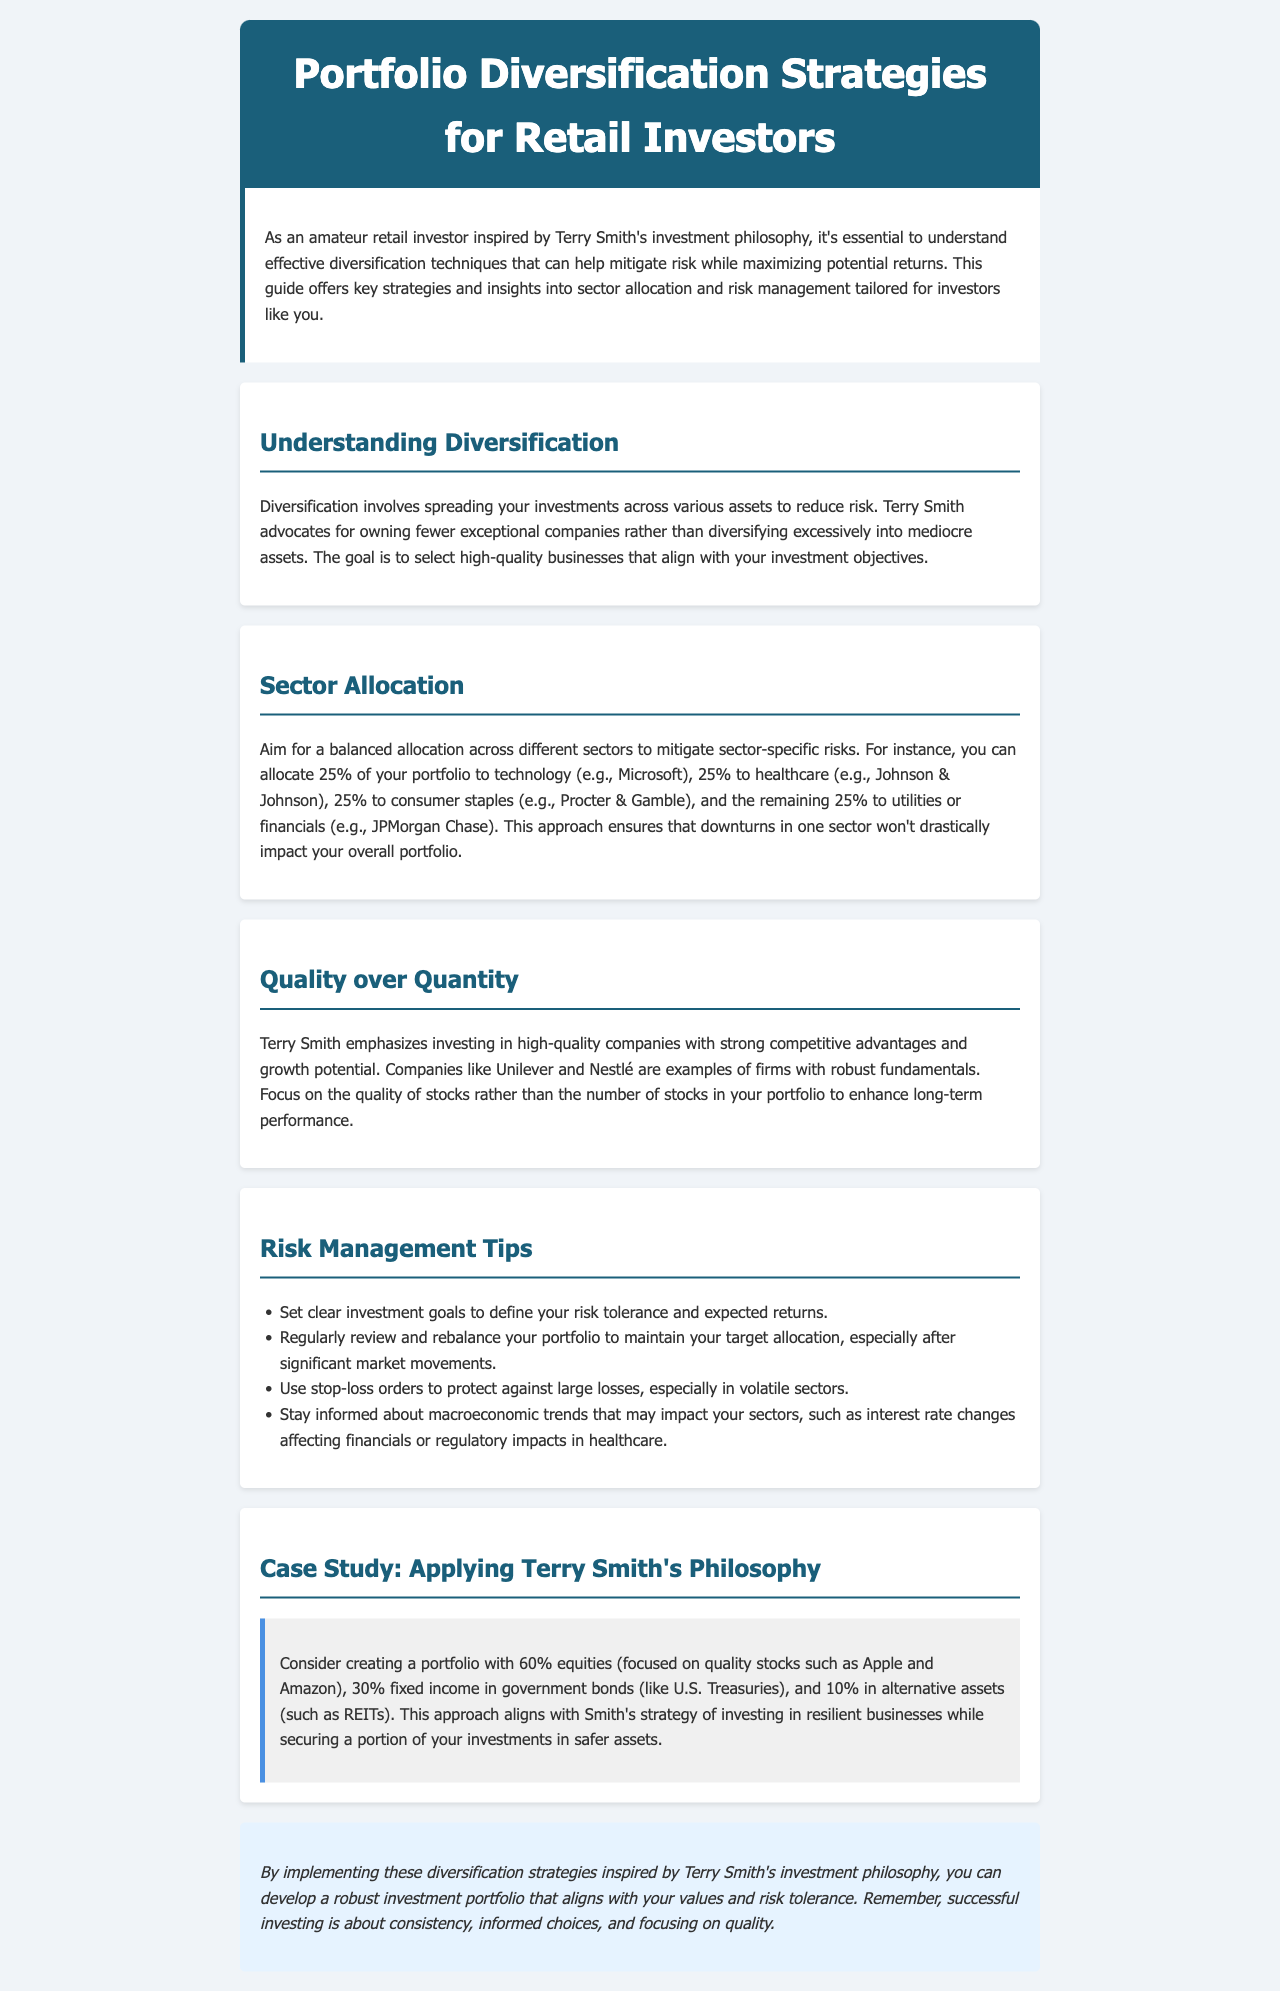What is the title of the document? The title of the document is presented in the header section of the newsletter.
Answer: Portfolio Diversification Strategies for Retail Investors What is Terry Smith's investment philosophy emphasized in the newsletter? The newsletter highlights Terry Smith's focus on investing in high-quality companies rather than diversifying excessively into mediocre assets.
Answer: Quality over quantity How much of the portfolio does the newsletter suggest allocating to technology? The newsletter specifies the allocation for different sectors, stating the percentage for technology explicitly.
Answer: 25% What is a recommended stock from the healthcare sector? The document provides specific examples of companies within each sector, including a healthcare company example.
Answer: Johnson & Johnson What is one of the risk management tips mentioned in the document? The document lists several risk management tips for retail investors, each focusing on strategies to mitigate risk.
Answer: Set clear investment goals What percentage of equities is suggested in the case study portfolio? The case study outlines the proposed asset allocation in percentages, specifically for equities.
Answer: 60% What percentage should be allocated to fixed income according to the case study? The case study details asset allocation, specifically mentioning the fixed income allocation percentage.
Answer: 30% What type of assets should comprise 10% of the portfolio as per the case study? The document specifies alternative assets as part of the portfolio allocation in the case study.
Answer: REITs What overarching theme does the conclusion reiterate? The conclusion summarizes the essence of the investment strategy discussed throughout the document.
Answer: Quality 